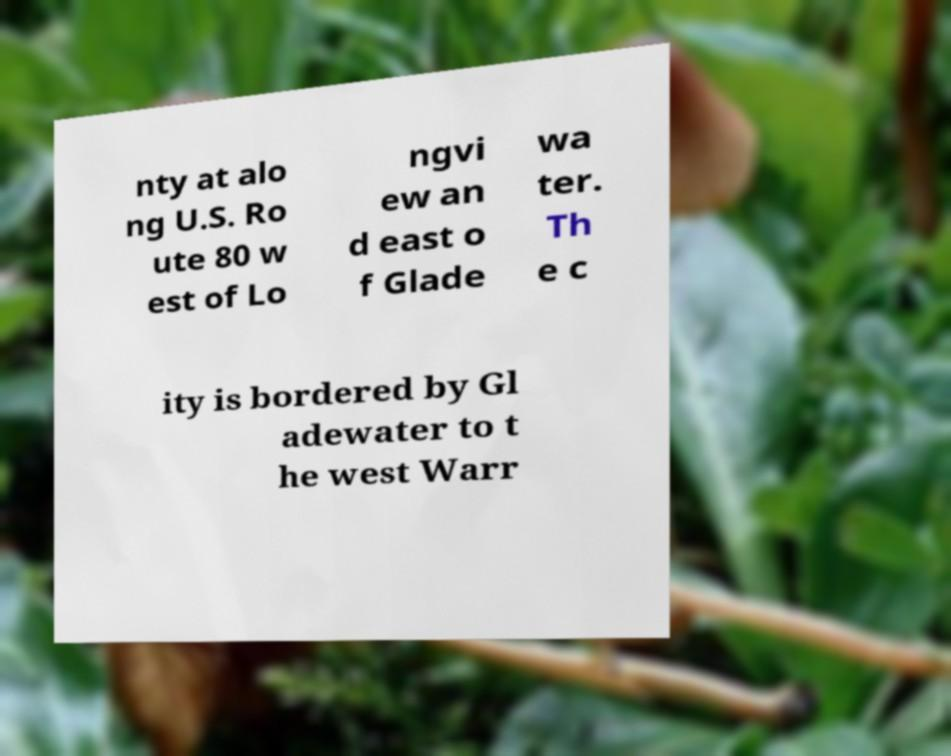For documentation purposes, I need the text within this image transcribed. Could you provide that? nty at alo ng U.S. Ro ute 80 w est of Lo ngvi ew an d east o f Glade wa ter. Th e c ity is bordered by Gl adewater to t he west Warr 